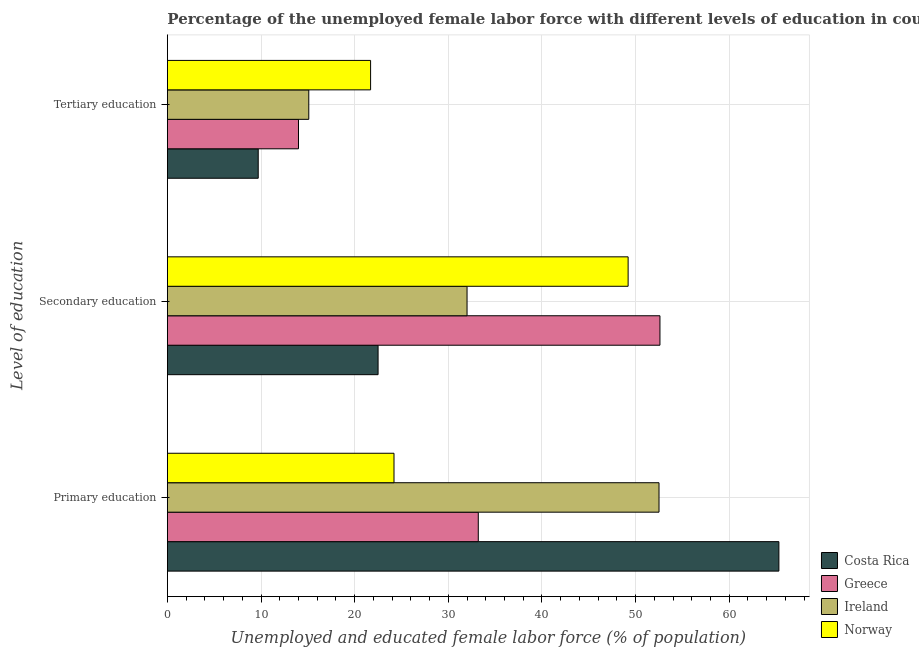How many different coloured bars are there?
Keep it short and to the point. 4. How many groups of bars are there?
Your answer should be very brief. 3. Are the number of bars on each tick of the Y-axis equal?
Keep it short and to the point. Yes. How many bars are there on the 1st tick from the bottom?
Give a very brief answer. 4. What is the percentage of female labor force who received tertiary education in Greece?
Make the answer very short. 14. Across all countries, what is the maximum percentage of female labor force who received primary education?
Provide a succinct answer. 65.3. Across all countries, what is the minimum percentage of female labor force who received primary education?
Make the answer very short. 24.2. In which country was the percentage of female labor force who received tertiary education maximum?
Your answer should be compact. Norway. What is the total percentage of female labor force who received primary education in the graph?
Your answer should be compact. 175.2. What is the difference between the percentage of female labor force who received secondary education in Norway and that in Costa Rica?
Your answer should be very brief. 26.7. What is the difference between the percentage of female labor force who received primary education in Greece and the percentage of female labor force who received secondary education in Ireland?
Ensure brevity in your answer.  1.2. What is the average percentage of female labor force who received tertiary education per country?
Your answer should be compact. 15.13. What is the difference between the percentage of female labor force who received secondary education and percentage of female labor force who received tertiary education in Ireland?
Give a very brief answer. 16.9. What is the ratio of the percentage of female labor force who received primary education in Greece to that in Costa Rica?
Keep it short and to the point. 0.51. What is the difference between the highest and the second highest percentage of female labor force who received secondary education?
Keep it short and to the point. 3.4. What is the difference between the highest and the lowest percentage of female labor force who received primary education?
Provide a short and direct response. 41.1. In how many countries, is the percentage of female labor force who received secondary education greater than the average percentage of female labor force who received secondary education taken over all countries?
Provide a succinct answer. 2. Is it the case that in every country, the sum of the percentage of female labor force who received primary education and percentage of female labor force who received secondary education is greater than the percentage of female labor force who received tertiary education?
Give a very brief answer. Yes. How many bars are there?
Your answer should be compact. 12. What is the difference between two consecutive major ticks on the X-axis?
Give a very brief answer. 10. Are the values on the major ticks of X-axis written in scientific E-notation?
Give a very brief answer. No. How are the legend labels stacked?
Your answer should be compact. Vertical. What is the title of the graph?
Keep it short and to the point. Percentage of the unemployed female labor force with different levels of education in countries. What is the label or title of the X-axis?
Keep it short and to the point. Unemployed and educated female labor force (% of population). What is the label or title of the Y-axis?
Your answer should be compact. Level of education. What is the Unemployed and educated female labor force (% of population) in Costa Rica in Primary education?
Give a very brief answer. 65.3. What is the Unemployed and educated female labor force (% of population) in Greece in Primary education?
Your answer should be compact. 33.2. What is the Unemployed and educated female labor force (% of population) in Ireland in Primary education?
Provide a succinct answer. 52.5. What is the Unemployed and educated female labor force (% of population) of Norway in Primary education?
Provide a succinct answer. 24.2. What is the Unemployed and educated female labor force (% of population) in Greece in Secondary education?
Keep it short and to the point. 52.6. What is the Unemployed and educated female labor force (% of population) in Norway in Secondary education?
Your answer should be compact. 49.2. What is the Unemployed and educated female labor force (% of population) of Costa Rica in Tertiary education?
Ensure brevity in your answer.  9.7. What is the Unemployed and educated female labor force (% of population) of Ireland in Tertiary education?
Make the answer very short. 15.1. What is the Unemployed and educated female labor force (% of population) of Norway in Tertiary education?
Your answer should be compact. 21.7. Across all Level of education, what is the maximum Unemployed and educated female labor force (% of population) of Costa Rica?
Give a very brief answer. 65.3. Across all Level of education, what is the maximum Unemployed and educated female labor force (% of population) in Greece?
Your answer should be compact. 52.6. Across all Level of education, what is the maximum Unemployed and educated female labor force (% of population) of Ireland?
Provide a succinct answer. 52.5. Across all Level of education, what is the maximum Unemployed and educated female labor force (% of population) in Norway?
Give a very brief answer. 49.2. Across all Level of education, what is the minimum Unemployed and educated female labor force (% of population) of Costa Rica?
Ensure brevity in your answer.  9.7. Across all Level of education, what is the minimum Unemployed and educated female labor force (% of population) in Greece?
Your answer should be very brief. 14. Across all Level of education, what is the minimum Unemployed and educated female labor force (% of population) in Ireland?
Give a very brief answer. 15.1. Across all Level of education, what is the minimum Unemployed and educated female labor force (% of population) in Norway?
Your answer should be very brief. 21.7. What is the total Unemployed and educated female labor force (% of population) of Costa Rica in the graph?
Your answer should be very brief. 97.5. What is the total Unemployed and educated female labor force (% of population) of Greece in the graph?
Provide a succinct answer. 99.8. What is the total Unemployed and educated female labor force (% of population) of Ireland in the graph?
Your answer should be very brief. 99.6. What is the total Unemployed and educated female labor force (% of population) in Norway in the graph?
Make the answer very short. 95.1. What is the difference between the Unemployed and educated female labor force (% of population) in Costa Rica in Primary education and that in Secondary education?
Your answer should be very brief. 42.8. What is the difference between the Unemployed and educated female labor force (% of population) of Greece in Primary education and that in Secondary education?
Provide a short and direct response. -19.4. What is the difference between the Unemployed and educated female labor force (% of population) of Costa Rica in Primary education and that in Tertiary education?
Provide a succinct answer. 55.6. What is the difference between the Unemployed and educated female labor force (% of population) in Ireland in Primary education and that in Tertiary education?
Make the answer very short. 37.4. What is the difference between the Unemployed and educated female labor force (% of population) in Costa Rica in Secondary education and that in Tertiary education?
Make the answer very short. 12.8. What is the difference between the Unemployed and educated female labor force (% of population) of Greece in Secondary education and that in Tertiary education?
Offer a very short reply. 38.6. What is the difference between the Unemployed and educated female labor force (% of population) of Norway in Secondary education and that in Tertiary education?
Your answer should be very brief. 27.5. What is the difference between the Unemployed and educated female labor force (% of population) in Costa Rica in Primary education and the Unemployed and educated female labor force (% of population) in Greece in Secondary education?
Offer a very short reply. 12.7. What is the difference between the Unemployed and educated female labor force (% of population) in Costa Rica in Primary education and the Unemployed and educated female labor force (% of population) in Ireland in Secondary education?
Your answer should be compact. 33.3. What is the difference between the Unemployed and educated female labor force (% of population) in Greece in Primary education and the Unemployed and educated female labor force (% of population) in Ireland in Secondary education?
Provide a short and direct response. 1.2. What is the difference between the Unemployed and educated female labor force (% of population) in Ireland in Primary education and the Unemployed and educated female labor force (% of population) in Norway in Secondary education?
Ensure brevity in your answer.  3.3. What is the difference between the Unemployed and educated female labor force (% of population) in Costa Rica in Primary education and the Unemployed and educated female labor force (% of population) in Greece in Tertiary education?
Make the answer very short. 51.3. What is the difference between the Unemployed and educated female labor force (% of population) of Costa Rica in Primary education and the Unemployed and educated female labor force (% of population) of Ireland in Tertiary education?
Your answer should be very brief. 50.2. What is the difference between the Unemployed and educated female labor force (% of population) of Costa Rica in Primary education and the Unemployed and educated female labor force (% of population) of Norway in Tertiary education?
Make the answer very short. 43.6. What is the difference between the Unemployed and educated female labor force (% of population) in Greece in Primary education and the Unemployed and educated female labor force (% of population) in Norway in Tertiary education?
Ensure brevity in your answer.  11.5. What is the difference between the Unemployed and educated female labor force (% of population) of Ireland in Primary education and the Unemployed and educated female labor force (% of population) of Norway in Tertiary education?
Ensure brevity in your answer.  30.8. What is the difference between the Unemployed and educated female labor force (% of population) in Costa Rica in Secondary education and the Unemployed and educated female labor force (% of population) in Norway in Tertiary education?
Your answer should be very brief. 0.8. What is the difference between the Unemployed and educated female labor force (% of population) in Greece in Secondary education and the Unemployed and educated female labor force (% of population) in Ireland in Tertiary education?
Your answer should be very brief. 37.5. What is the difference between the Unemployed and educated female labor force (% of population) of Greece in Secondary education and the Unemployed and educated female labor force (% of population) of Norway in Tertiary education?
Your answer should be compact. 30.9. What is the difference between the Unemployed and educated female labor force (% of population) in Ireland in Secondary education and the Unemployed and educated female labor force (% of population) in Norway in Tertiary education?
Your response must be concise. 10.3. What is the average Unemployed and educated female labor force (% of population) in Costa Rica per Level of education?
Give a very brief answer. 32.5. What is the average Unemployed and educated female labor force (% of population) in Greece per Level of education?
Ensure brevity in your answer.  33.27. What is the average Unemployed and educated female labor force (% of population) of Ireland per Level of education?
Keep it short and to the point. 33.2. What is the average Unemployed and educated female labor force (% of population) in Norway per Level of education?
Your answer should be very brief. 31.7. What is the difference between the Unemployed and educated female labor force (% of population) of Costa Rica and Unemployed and educated female labor force (% of population) of Greece in Primary education?
Provide a short and direct response. 32.1. What is the difference between the Unemployed and educated female labor force (% of population) of Costa Rica and Unemployed and educated female labor force (% of population) of Norway in Primary education?
Offer a very short reply. 41.1. What is the difference between the Unemployed and educated female labor force (% of population) of Greece and Unemployed and educated female labor force (% of population) of Ireland in Primary education?
Provide a succinct answer. -19.3. What is the difference between the Unemployed and educated female labor force (% of population) of Greece and Unemployed and educated female labor force (% of population) of Norway in Primary education?
Keep it short and to the point. 9. What is the difference between the Unemployed and educated female labor force (% of population) in Ireland and Unemployed and educated female labor force (% of population) in Norway in Primary education?
Offer a very short reply. 28.3. What is the difference between the Unemployed and educated female labor force (% of population) in Costa Rica and Unemployed and educated female labor force (% of population) in Greece in Secondary education?
Give a very brief answer. -30.1. What is the difference between the Unemployed and educated female labor force (% of population) of Costa Rica and Unemployed and educated female labor force (% of population) of Norway in Secondary education?
Provide a short and direct response. -26.7. What is the difference between the Unemployed and educated female labor force (% of population) in Greece and Unemployed and educated female labor force (% of population) in Ireland in Secondary education?
Ensure brevity in your answer.  20.6. What is the difference between the Unemployed and educated female labor force (% of population) of Ireland and Unemployed and educated female labor force (% of population) of Norway in Secondary education?
Your answer should be very brief. -17.2. What is the difference between the Unemployed and educated female labor force (% of population) in Costa Rica and Unemployed and educated female labor force (% of population) in Greece in Tertiary education?
Give a very brief answer. -4.3. What is the difference between the Unemployed and educated female labor force (% of population) in Greece and Unemployed and educated female labor force (% of population) in Ireland in Tertiary education?
Offer a terse response. -1.1. What is the difference between the Unemployed and educated female labor force (% of population) of Greece and Unemployed and educated female labor force (% of population) of Norway in Tertiary education?
Your response must be concise. -7.7. What is the ratio of the Unemployed and educated female labor force (% of population) in Costa Rica in Primary education to that in Secondary education?
Provide a succinct answer. 2.9. What is the ratio of the Unemployed and educated female labor force (% of population) of Greece in Primary education to that in Secondary education?
Your answer should be very brief. 0.63. What is the ratio of the Unemployed and educated female labor force (% of population) in Ireland in Primary education to that in Secondary education?
Provide a short and direct response. 1.64. What is the ratio of the Unemployed and educated female labor force (% of population) of Norway in Primary education to that in Secondary education?
Offer a terse response. 0.49. What is the ratio of the Unemployed and educated female labor force (% of population) in Costa Rica in Primary education to that in Tertiary education?
Keep it short and to the point. 6.73. What is the ratio of the Unemployed and educated female labor force (% of population) in Greece in Primary education to that in Tertiary education?
Provide a succinct answer. 2.37. What is the ratio of the Unemployed and educated female labor force (% of population) of Ireland in Primary education to that in Tertiary education?
Your response must be concise. 3.48. What is the ratio of the Unemployed and educated female labor force (% of population) in Norway in Primary education to that in Tertiary education?
Keep it short and to the point. 1.12. What is the ratio of the Unemployed and educated female labor force (% of population) in Costa Rica in Secondary education to that in Tertiary education?
Your answer should be very brief. 2.32. What is the ratio of the Unemployed and educated female labor force (% of population) in Greece in Secondary education to that in Tertiary education?
Your answer should be very brief. 3.76. What is the ratio of the Unemployed and educated female labor force (% of population) of Ireland in Secondary education to that in Tertiary education?
Your answer should be compact. 2.12. What is the ratio of the Unemployed and educated female labor force (% of population) of Norway in Secondary education to that in Tertiary education?
Your answer should be compact. 2.27. What is the difference between the highest and the second highest Unemployed and educated female labor force (% of population) of Costa Rica?
Your response must be concise. 42.8. What is the difference between the highest and the lowest Unemployed and educated female labor force (% of population) of Costa Rica?
Give a very brief answer. 55.6. What is the difference between the highest and the lowest Unemployed and educated female labor force (% of population) in Greece?
Offer a very short reply. 38.6. What is the difference between the highest and the lowest Unemployed and educated female labor force (% of population) of Ireland?
Provide a short and direct response. 37.4. 